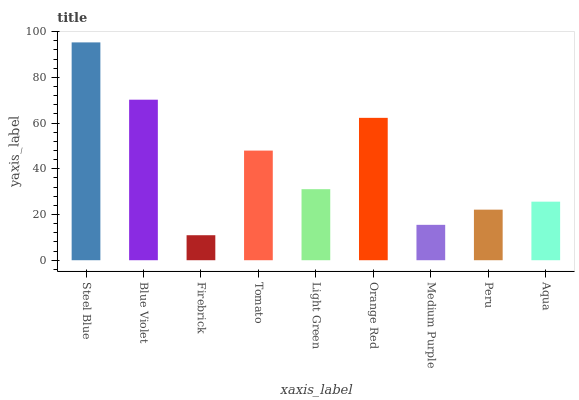Is Firebrick the minimum?
Answer yes or no. Yes. Is Steel Blue the maximum?
Answer yes or no. Yes. Is Blue Violet the minimum?
Answer yes or no. No. Is Blue Violet the maximum?
Answer yes or no. No. Is Steel Blue greater than Blue Violet?
Answer yes or no. Yes. Is Blue Violet less than Steel Blue?
Answer yes or no. Yes. Is Blue Violet greater than Steel Blue?
Answer yes or no. No. Is Steel Blue less than Blue Violet?
Answer yes or no. No. Is Light Green the high median?
Answer yes or no. Yes. Is Light Green the low median?
Answer yes or no. Yes. Is Peru the high median?
Answer yes or no. No. Is Blue Violet the low median?
Answer yes or no. No. 